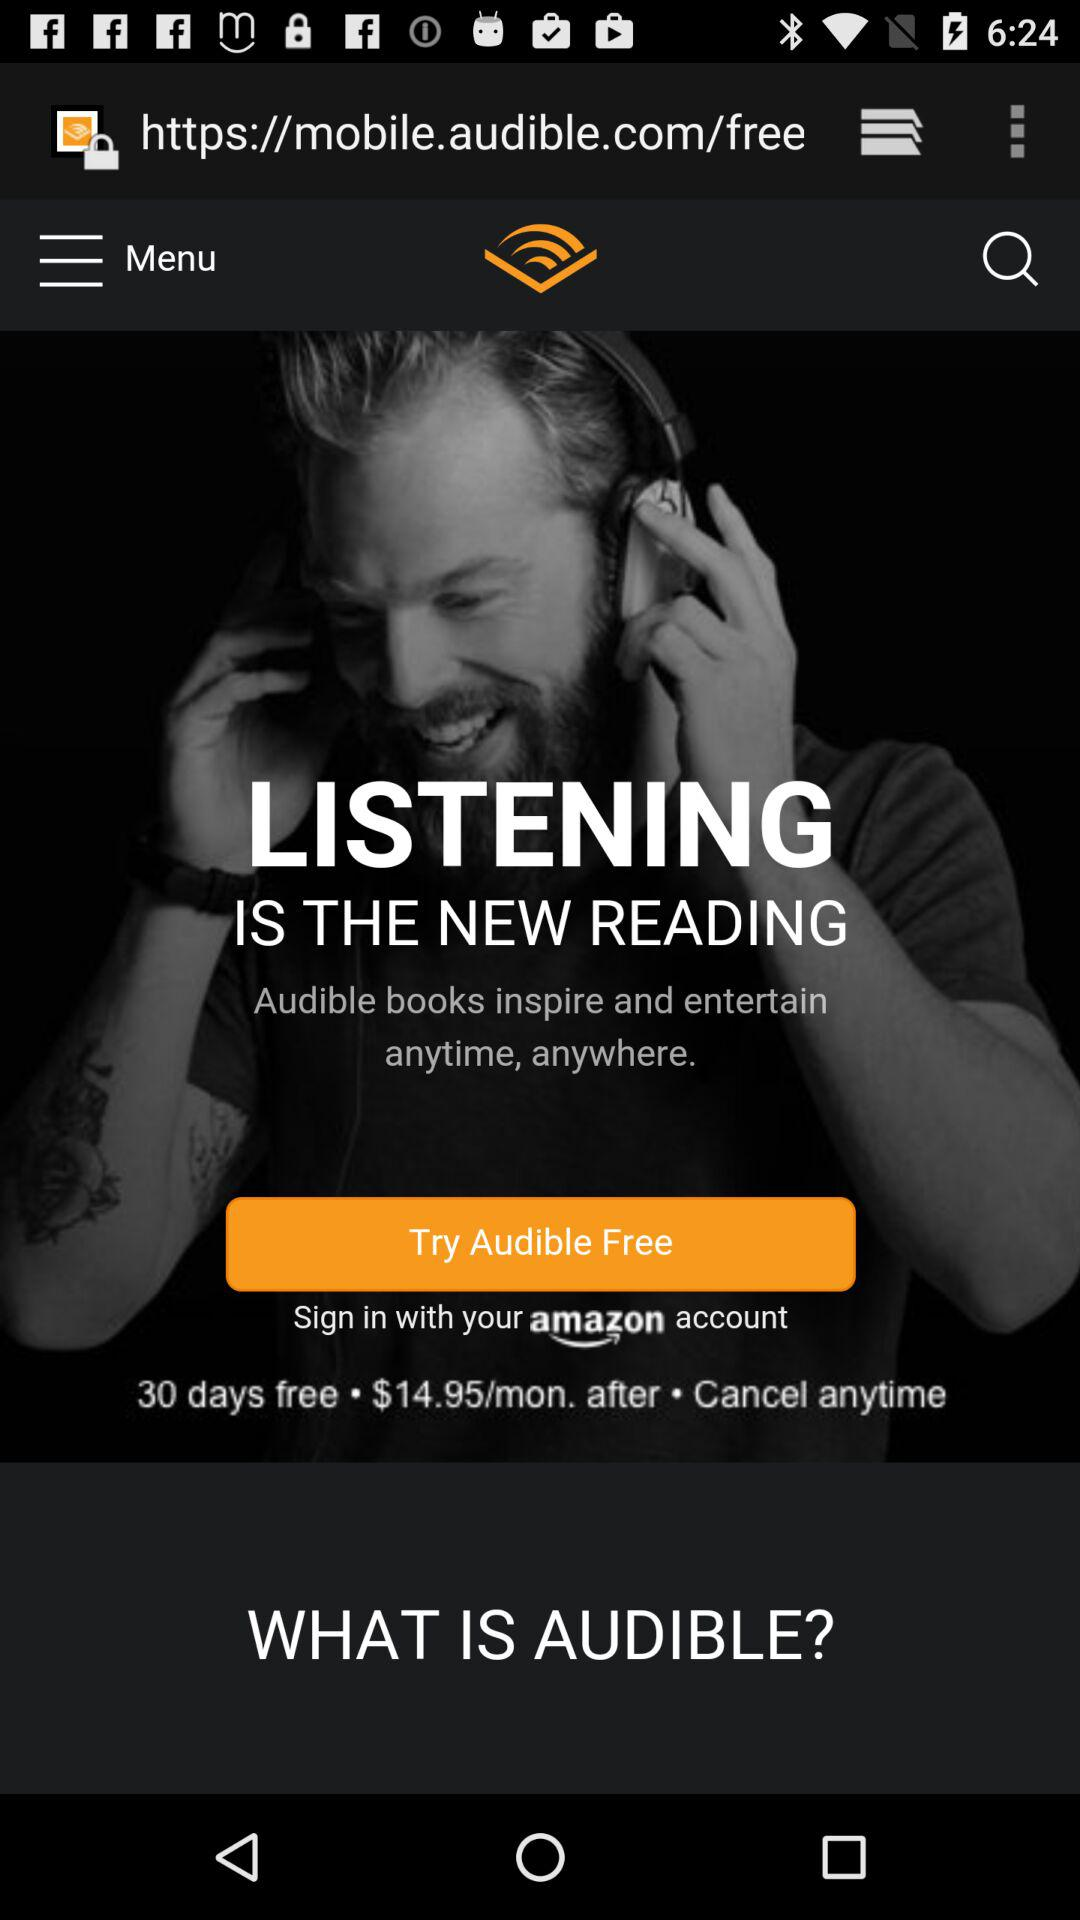What is the name of the application? The name of the application is "Audible". 